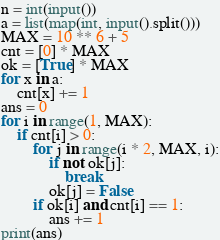Convert code to text. <code><loc_0><loc_0><loc_500><loc_500><_Python_>n = int(input())
a = list(map(int, input().split()))
MAX = 10 ** 6 + 5
cnt = [0] * MAX
ok = [True] * MAX
for x in a:
    cnt[x] += 1
ans = 0
for i in range(1, MAX):
    if cnt[i] > 0:
        for j in range(i * 2, MAX, i):
            if not ok[j]:
                break
            ok[j] = False      
        if ok[i] and cnt[i] == 1:
            ans += 1
print(ans)</code> 